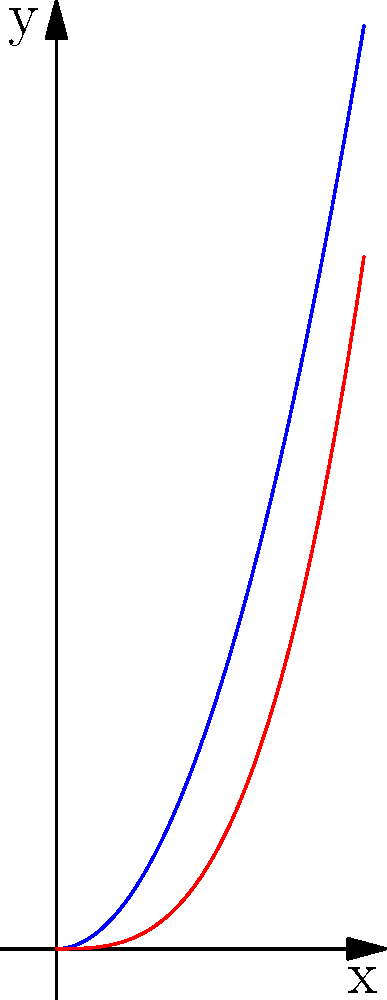In a biological study of two species' habitats, the boundary of Species A's habitat is represented by the function $f(x) = 2x^2$, while Species B's habitat boundary is given by $g(x) = x^3$. Calculate the area of the overlapping region between these two habitats in the interval $[0,1]$. How might this information be relevant to government policy on habitat conservation? To solve this problem, we need to follow these steps:

1) First, we need to find the area between the two curves. This is given by the definite integral of the difference between the upper and lower functions:

   $$\text{Area} = \int_{0}^{1} (f(x) - g(x)) dx$$

2) Substituting our functions:

   $$\text{Area} = \int_{0}^{1} (2x^2 - x^3) dx$$

3) Now we integrate:

   $$\text{Area} = \left[\frac{2x^3}{3} - \frac{x^4}{4}\right]_{0}^{1}$$

4) Evaluate the integral at the limits:

   $$\text{Area} = \left(\frac{2}{3} - \frac{1}{4}\right) - (0 - 0) = \frac{2}{3} - \frac{1}{4} = \frac{8}{12} - \frac{3}{12} = \frac{5}{12}$$

This result shows the overlapping area of the two species' habitats. In terms of government policy and habitat conservation, this information could be crucial for:

1) Determining the extent of shared resources between species
2) Assessing the potential for inter-species competition
3) Planning conservation efforts that benefit multiple species
4) Allocating budget for habitat protection based on the degree of overlap
5) Developing policies that consider the interconnectedness of different species' habitats
Answer: $\frac{5}{12}$ square units 